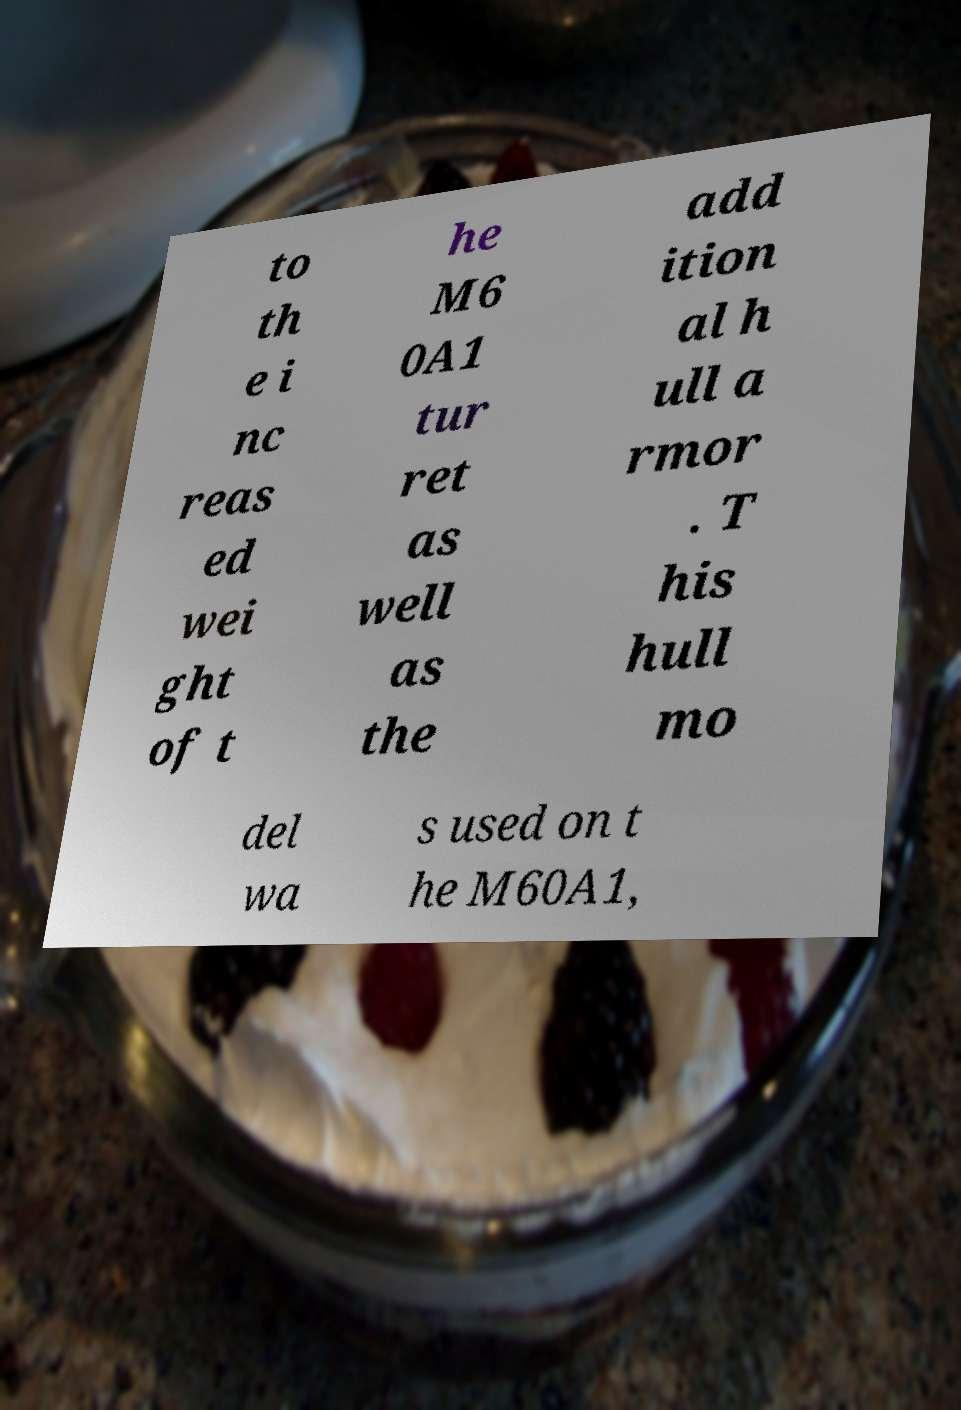For documentation purposes, I need the text within this image transcribed. Could you provide that? to th e i nc reas ed wei ght of t he M6 0A1 tur ret as well as the add ition al h ull a rmor . T his hull mo del wa s used on t he M60A1, 